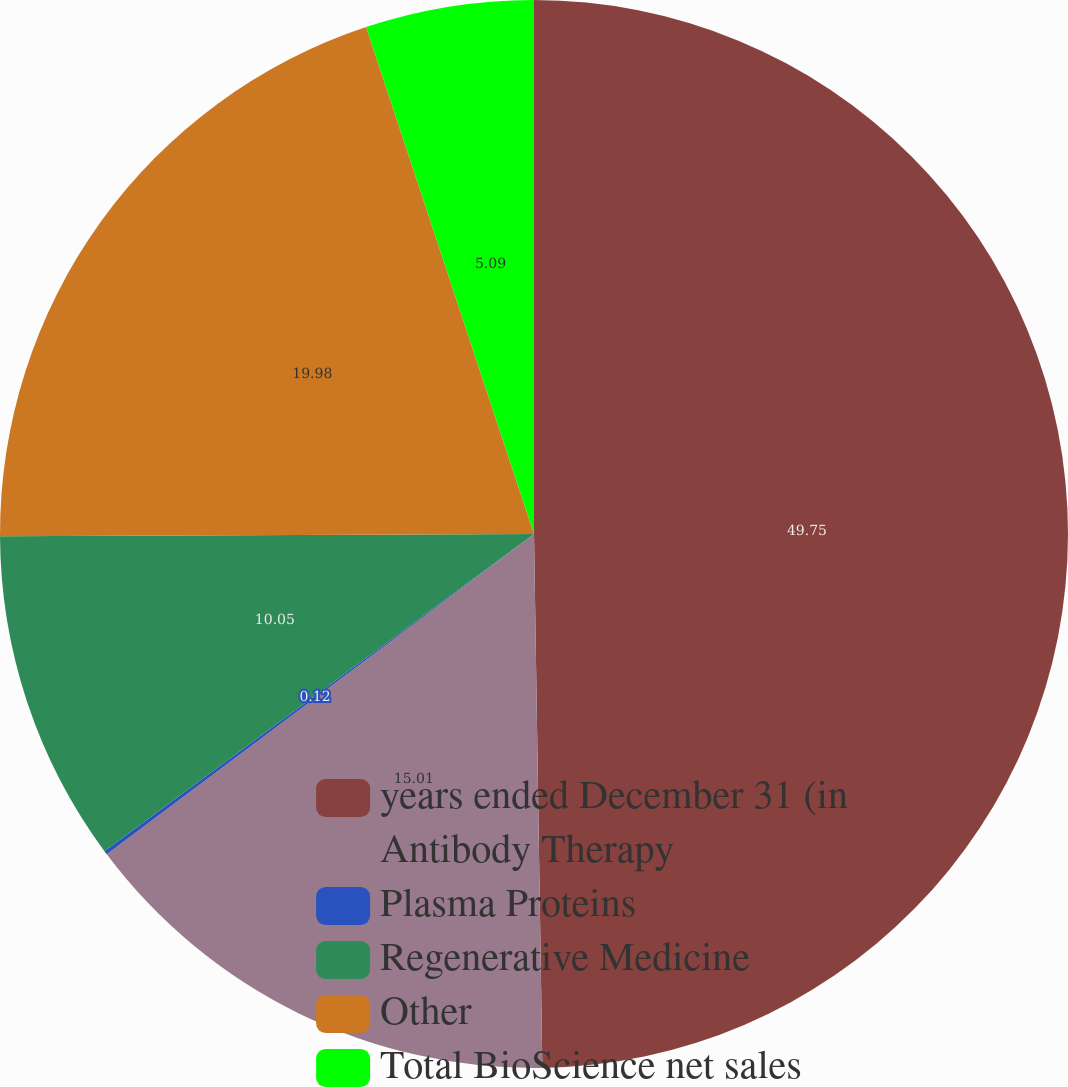Convert chart to OTSL. <chart><loc_0><loc_0><loc_500><loc_500><pie_chart><fcel>years ended December 31 (in<fcel>Antibody Therapy<fcel>Plasma Proteins<fcel>Regenerative Medicine<fcel>Other<fcel>Total BioScience net sales<nl><fcel>49.75%<fcel>15.01%<fcel>0.12%<fcel>10.05%<fcel>19.98%<fcel>5.09%<nl></chart> 